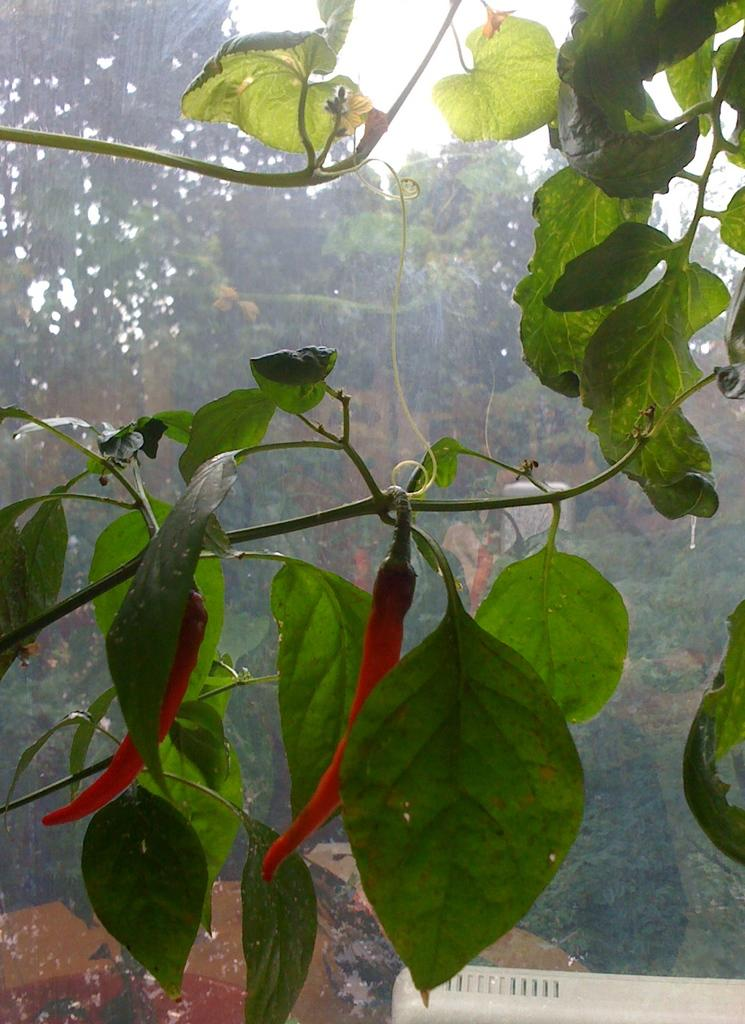What type of plant is in the image? There is a creeper in the image. What features can be observed on the creeper? The creeper has leaves and red chilies on its stem. What is located behind the creeper? There is a glass behind the creeper. What can be seen outside the glass? Trees and the sky are visible outside the glass. Where can you find the stove in the image? There is no stove present in the image. What type of hose is connected to the creeper in the image? There is no hose connected to the creeper in the image. 